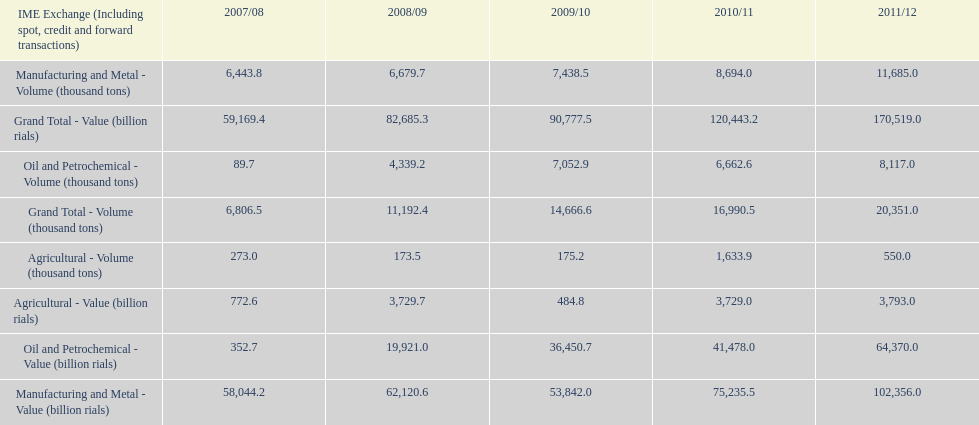What year saw the greatest value for manufacturing and metal in iran? 2011/12. 